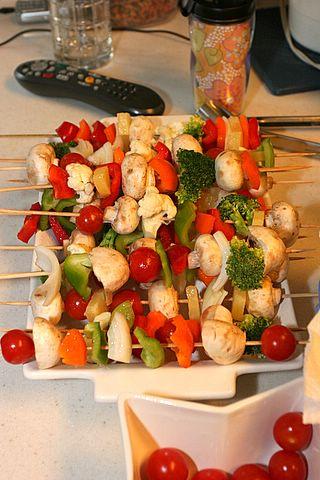Do you prepare food like that on the grill?
Give a very brief answer. Yes. Are there mushrooms?
Answer briefly. Yes. Where is the remote control?
Be succinct. By glass. 